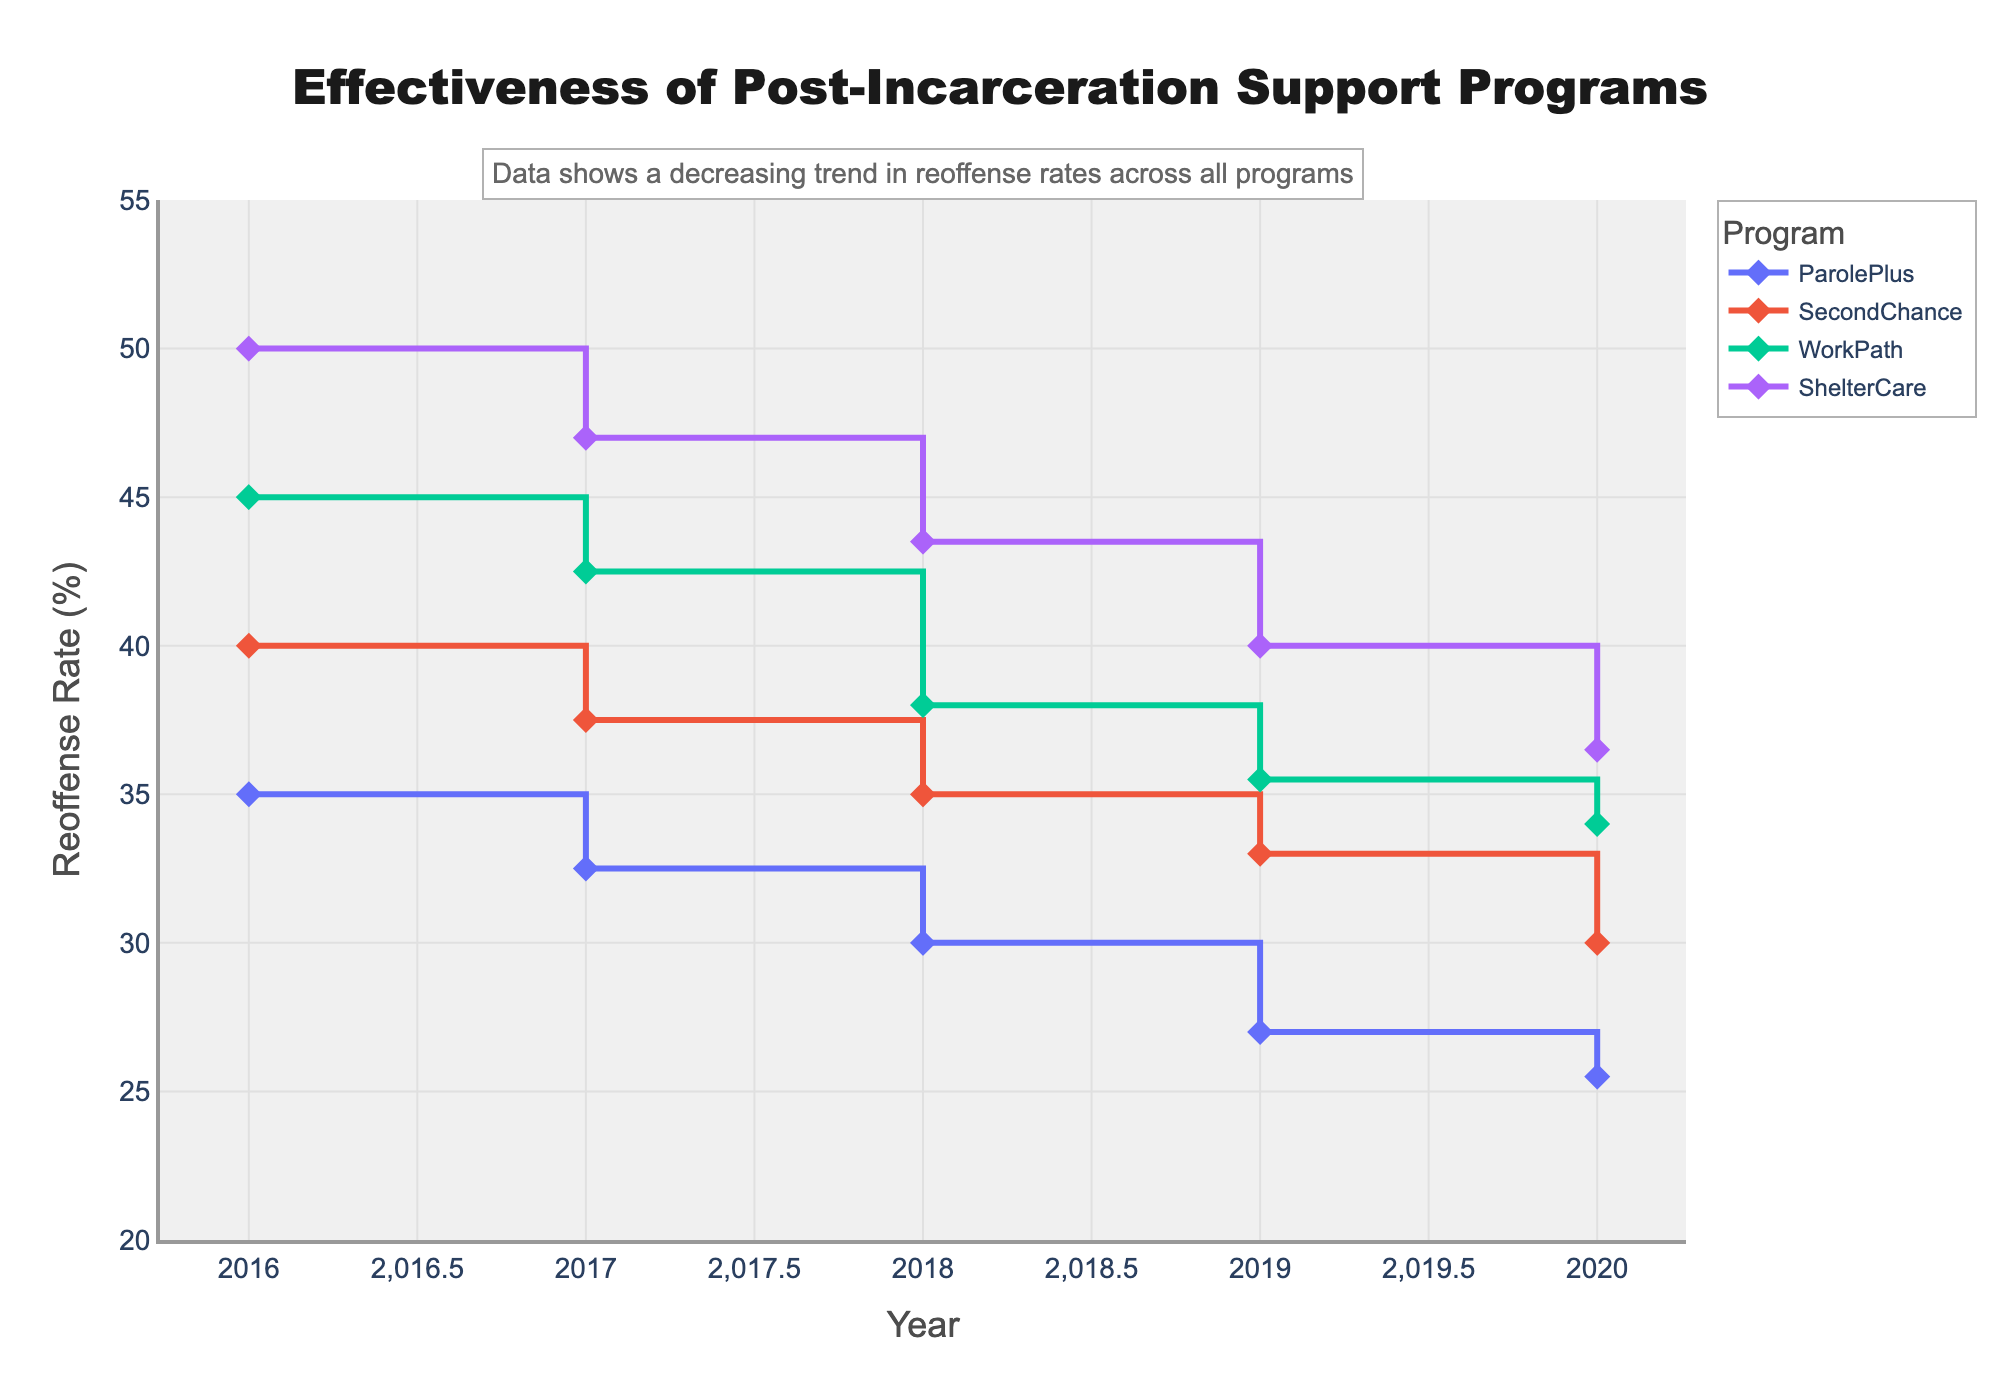what is the title of the plot? The title is typically located at the top of the figure, and in this case, it says, "Effectiveness of Post-Incarceration Support Programs".
Answer: Effectiveness of Post-Incarceration Support Programs What is the y-axis title? The y-axis title is found along the vertical axis, showing what is being measured, which in this case is "Reoffense Rate (%)".
Answer: Reoffense Rate (%) How many support programs are shown? Each unique line in the stair plot represents a different support program. By counting the unique names in the legend or lines in the plot, we can determine there are four programs: ParolePlus, SecondChance, WorkPath, and ShelterCare.
Answer: four Which program had the highest reoffense rate in 2016? We need to look at the values for all programs in 2016. ParolePlus: 35.0, SecondChance: 40.0, WorkPath: 45.0, ShelterCare: 50.0. The highest value is 50.0 for ShelterCare.
Answer: ShelterCare By how much did the reoffense rate for ParolePlus decrease from 2016 to 2020? Look at the reoffense rates for ParolePlus in 2016 (35.0) and 2020 (25.5). Calculate the difference: 35.0 - 25.5 = 9.5.
Answer: 9.5 Among all programs, which had the smallest decrease in the reoffense rate from 2016 to 2020? Calculate the decrease for each program: ParolePlus (35.0-25.5=9.5), SecondChance (40.0-30.0=10.0), WorkPath (45.0-34.0=11.0), ShelterCare (50.0-36.5=13.5). The smallest decrease is 9.5 for ParolePlus.
Answer: ParolePlus Which program had a steady decrease each year in reoffense rate? Examine the trend in reoffense rates for each program year by year. ParolePlus, SecondChance, and WorkPath all have consistent decreases each year. However, ShelterCare also decreases steadily each year.
Answer: All programs What is the average reoffense rate for WorkPath from 2016 to 2020? Add the reoffense rates for WorkPath from 2016-2020 (45.0 + 42.5 + 38.0 + 35.5 + 34.0) = 195.0. Divide this sum by the number of years 195.0/5 = 39.0.
Answer: 39.0 In which year did SecondChance have the greatest reoffense rate decrease compared to the previous year? Calculate the year-to-year differences for SecondChance: 40.0-37.5=2.5 (2016-2017), 37.5-35.0=2.5 (2017-2018), 35.0-33.0=2.0 (2018-2019), 33.0-30.0=3.0 (2019-2020). The greatest decrease is 3.0 from 2019 to 2020.
Answer: 2019 to 2020 Among the years 2016 to 2020, which year saw the lowest reoffense rate across all programs? Look at the reoffense rates for all programs each year and identify the lowest value for each year: 2016 (35, 40, 45, 50), 2017 (32.5, 37.5, 42.5, 47), 2018 (30, 35, 38, 43.5), 2019 (27, 33, 35.5, 40), 2020 (25.5, 30, 34, 36.5). The lowest value overall is 25.5 in 2020 for ParolePlus.
Answer: 2020 